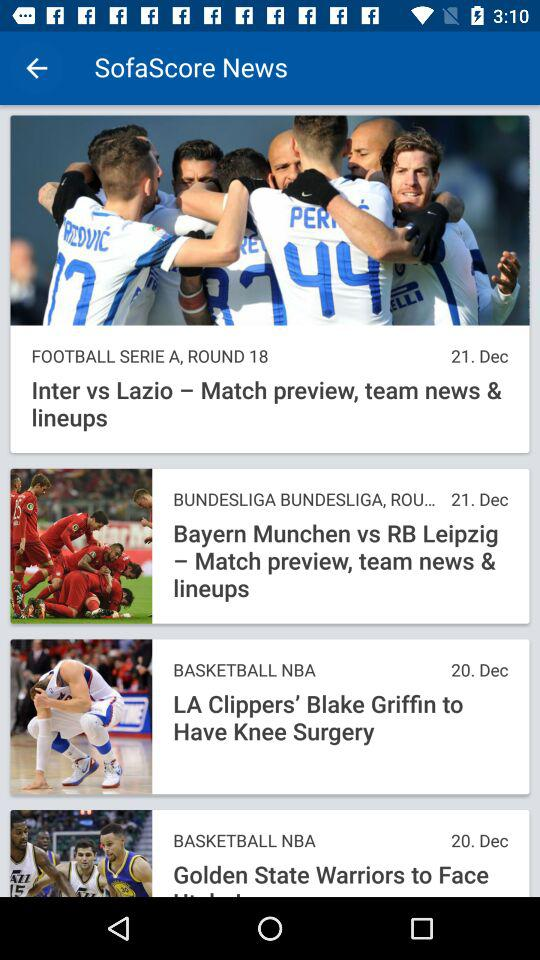On what date was the news about the match between "Bayern Munchen" and "RB Leipzig" posted? The news about the match between "Bayern Munchen" and "RB Leipzig" was posted on December 21. 